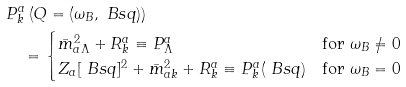<formula> <loc_0><loc_0><loc_500><loc_500>& P ^ { a } _ { k } \left ( Q = ( \omega _ { B } , \ B s q ) \right ) \\ & \quad = \begin{cases} \bar { m } _ { a \Lambda } ^ { 2 } + R ^ { a } _ { k } \equiv P ^ { a } _ { \Lambda } & \text {for } \omega _ { B } \neq 0 \\ Z _ { a } [ \ B s q ] ^ { 2 } + \bar { m } _ { a k } ^ { 2 } + R ^ { a } _ { k } \equiv P ^ { a } _ { k } ( \ B s q ) & \text {for } \omega _ { B } = 0 \end{cases}</formula> 